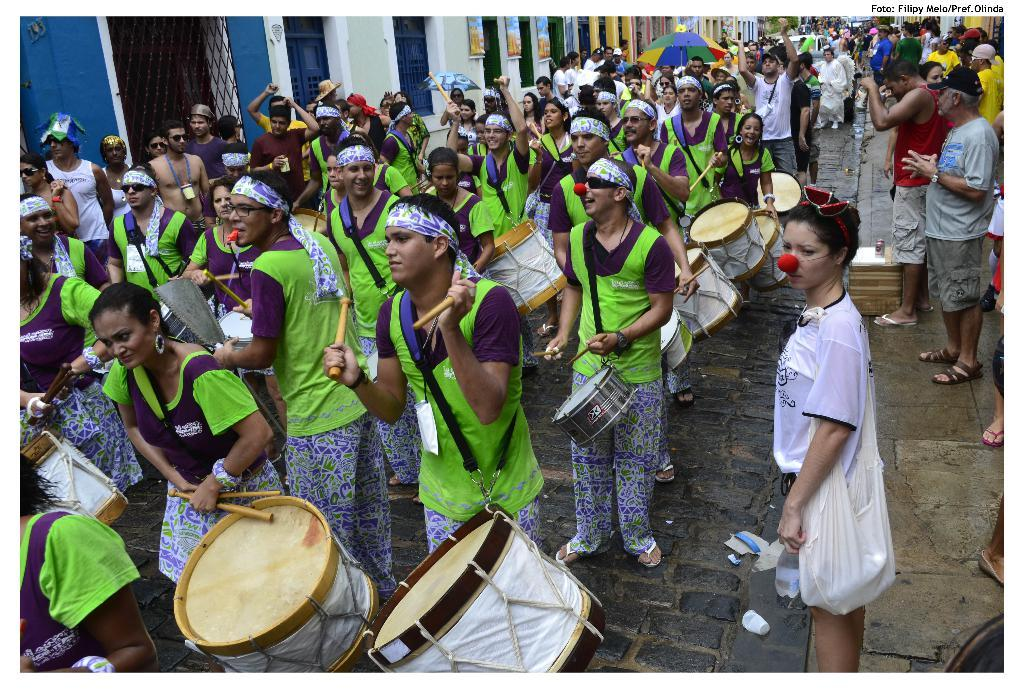What are the people on the road doing? The people on the road are marching. What activity are they engaged in while marching? They are playing drums. How are the people on either side of the road reacting to the marching and drum playing? People on either side of the road are looking at them. Can you see a snake slithering among the marching people in the image? There is no snake present in the image; it only features people marching and playing drums. What type of thought is being expressed by the people on either side of the road? The image does not provide any information about the thoughts of the people on either side of the road. 